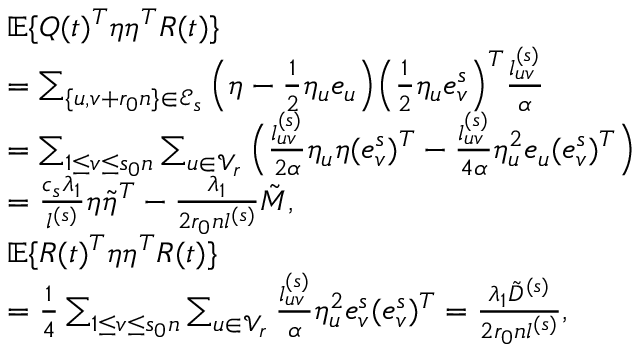<formula> <loc_0><loc_0><loc_500><loc_500>\begin{array} { r l } & { \mathbb { E } \{ Q ( t ) ^ { T } \eta \eta ^ { T } R ( t ) \} } \\ & { = \sum _ { \{ u , v + r _ { 0 } n \} \in \mathcal { E } _ { s } } \left ( \eta - \frac { 1 } { 2 } \eta _ { u } e _ { u } \right ) \left ( \frac { 1 } { 2 } \eta _ { u } e _ { v } ^ { s } \right ) ^ { T } \frac { l _ { u v } ^ { ( s ) } } { \alpha } } \\ & { = \sum _ { 1 \leq v \leq s _ { 0 } n } \sum _ { u \in \mathcal { V } _ { r } } \left ( \frac { l _ { u v } ^ { ( s ) } } { 2 \alpha } \eta _ { u } \eta ( e _ { v } ^ { s } ) ^ { T } - \frac { l _ { u v } ^ { ( s ) } } { 4 \alpha } \eta _ { u } ^ { 2 } e _ { u } ( e _ { v } ^ { s } ) ^ { T } \right ) } \\ & { = \frac { c _ { s } \lambda _ { 1 } } { l ^ { ( s ) } } \eta \tilde { \eta } ^ { T } - \frac { \lambda _ { 1 } } { 2 r _ { 0 } n l ^ { ( s ) } } \tilde { M } , } \\ & { \mathbb { E } \{ R ( t ) ^ { T } \eta \eta ^ { T } R ( t ) \} } \\ & { = \frac { 1 } { 4 } \sum _ { 1 \leq v \leq s _ { 0 } n } \sum _ { u \in \mathcal { V } _ { r } } \frac { l _ { u v } ^ { ( s ) } } { \alpha } \eta _ { u } ^ { 2 } e _ { v } ^ { s } ( e _ { v } ^ { s } ) ^ { T } = \frac { \lambda _ { 1 } \tilde { D } ^ { ( s ) } } { 2 r _ { 0 } n l ^ { ( s ) } } , } \end{array}</formula> 